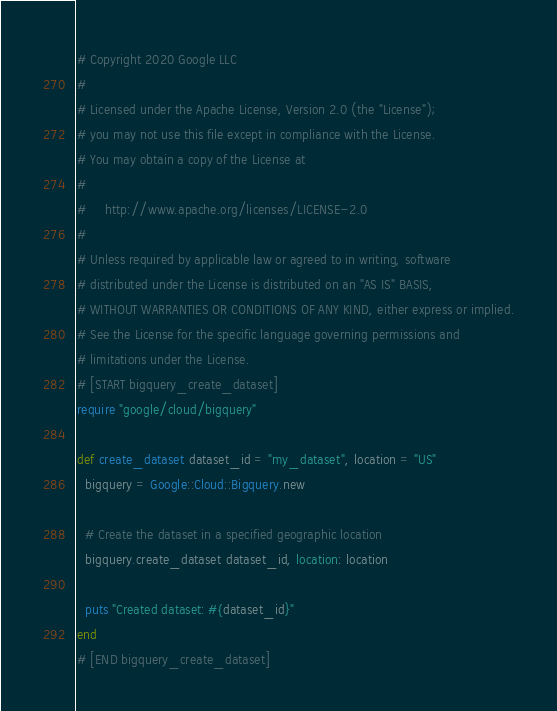<code> <loc_0><loc_0><loc_500><loc_500><_Ruby_># Copyright 2020 Google LLC
#
# Licensed under the Apache License, Version 2.0 (the "License");
# you may not use this file except in compliance with the License.
# You may obtain a copy of the License at
#
#     http://www.apache.org/licenses/LICENSE-2.0
#
# Unless required by applicable law or agreed to in writing, software
# distributed under the License is distributed on an "AS IS" BASIS,
# WITHOUT WARRANTIES OR CONDITIONS OF ANY KIND, either express or implied.
# See the License for the specific language governing permissions and
# limitations under the License.
# [START bigquery_create_dataset]
require "google/cloud/bigquery"

def create_dataset dataset_id = "my_dataset", location = "US"
  bigquery = Google::Cloud::Bigquery.new

  # Create the dataset in a specified geographic location
  bigquery.create_dataset dataset_id, location: location

  puts "Created dataset: #{dataset_id}"
end
# [END bigquery_create_dataset]
</code> 